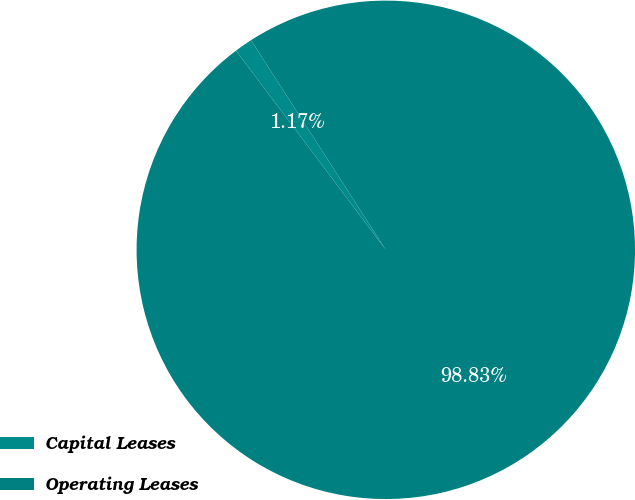<chart> <loc_0><loc_0><loc_500><loc_500><pie_chart><fcel>Capital Leases<fcel>Operating Leases<nl><fcel>1.17%<fcel>98.83%<nl></chart> 